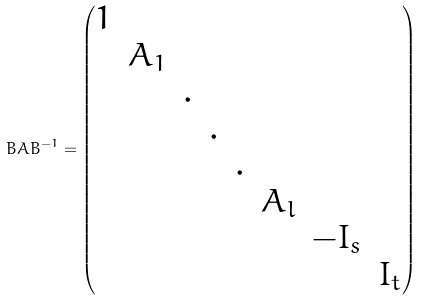<formula> <loc_0><loc_0><loc_500><loc_500>B A B ^ { - 1 } = \begin{pmatrix} 1 & & & & & & & \\ & A _ { 1 } & & & & & & \\ & & . & & & & & \\ & & & . & & & & \\ & & & & . & & & \\ & & & & & A _ { l } & & \\ & & & & & & - I _ { s } & \\ & & & & & & & I _ { t } \end{pmatrix}</formula> 